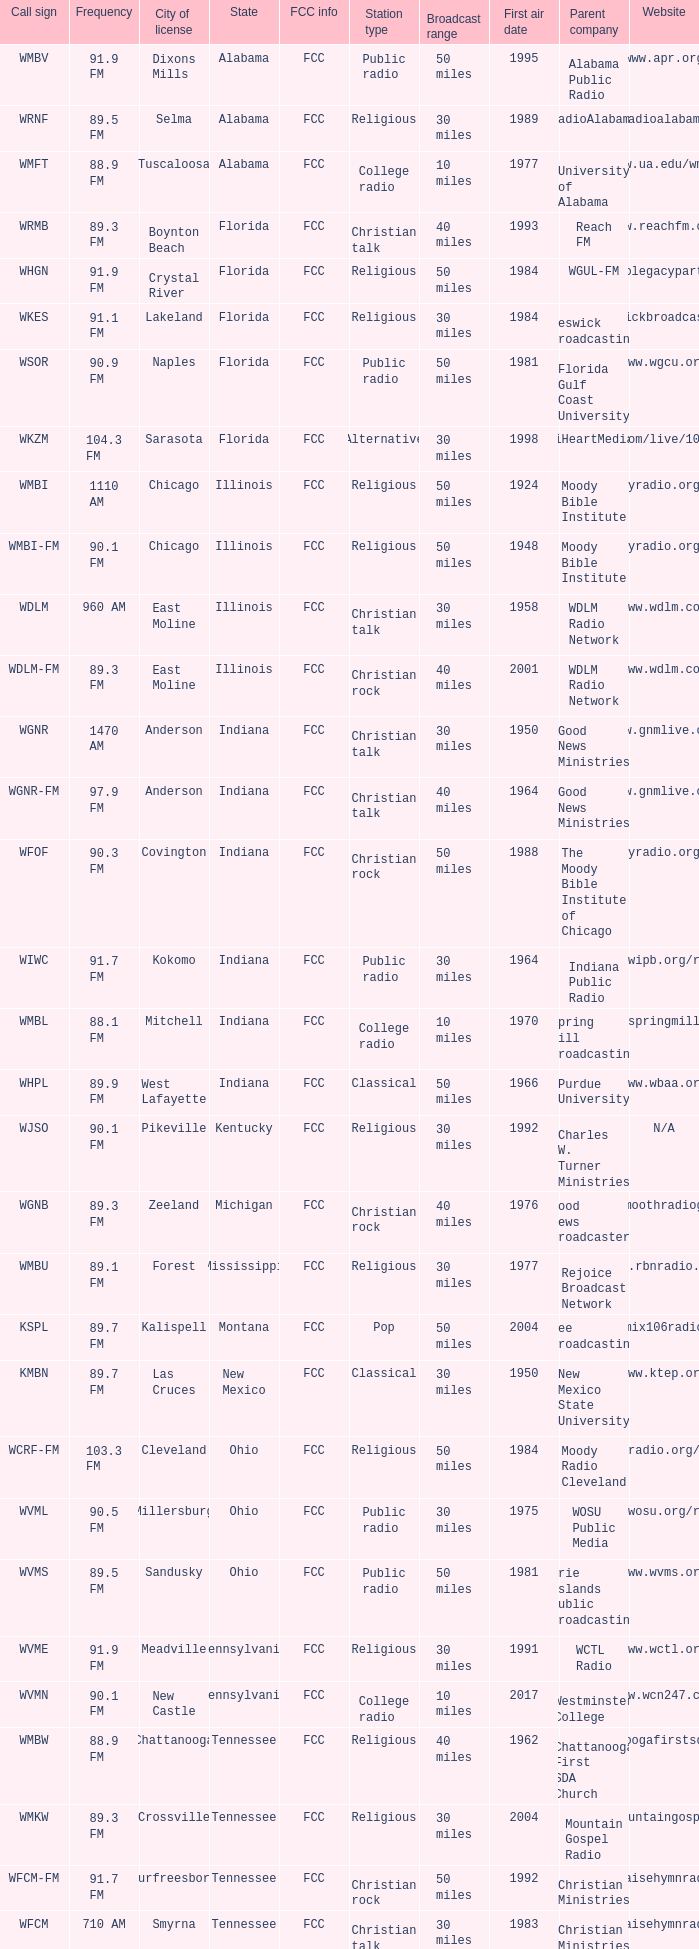What is the rate of recurrence for the radio station in indiana with a call sign wgnr? 1470 AM. 